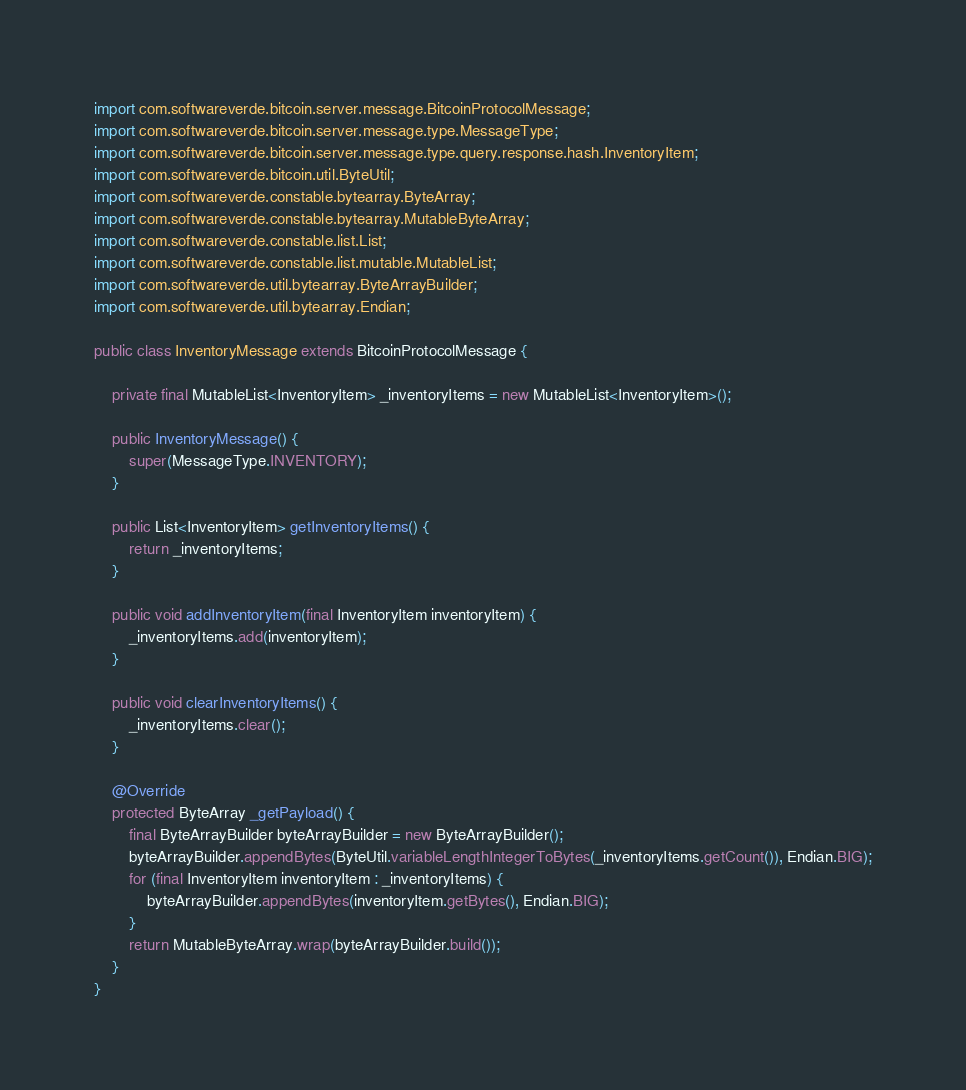<code> <loc_0><loc_0><loc_500><loc_500><_Java_>import com.softwareverde.bitcoin.server.message.BitcoinProtocolMessage;
import com.softwareverde.bitcoin.server.message.type.MessageType;
import com.softwareverde.bitcoin.server.message.type.query.response.hash.InventoryItem;
import com.softwareverde.bitcoin.util.ByteUtil;
import com.softwareverde.constable.bytearray.ByteArray;
import com.softwareverde.constable.bytearray.MutableByteArray;
import com.softwareverde.constable.list.List;
import com.softwareverde.constable.list.mutable.MutableList;
import com.softwareverde.util.bytearray.ByteArrayBuilder;
import com.softwareverde.util.bytearray.Endian;

public class InventoryMessage extends BitcoinProtocolMessage {

    private final MutableList<InventoryItem> _inventoryItems = new MutableList<InventoryItem>();

    public InventoryMessage() {
        super(MessageType.INVENTORY);
    }

    public List<InventoryItem> getInventoryItems() {
        return _inventoryItems;
    }

    public void addInventoryItem(final InventoryItem inventoryItem) {
        _inventoryItems.add(inventoryItem);
    }

    public void clearInventoryItems() {
        _inventoryItems.clear();
    }

    @Override
    protected ByteArray _getPayload() {
        final ByteArrayBuilder byteArrayBuilder = new ByteArrayBuilder();
        byteArrayBuilder.appendBytes(ByteUtil.variableLengthIntegerToBytes(_inventoryItems.getCount()), Endian.BIG);
        for (final InventoryItem inventoryItem : _inventoryItems) {
            byteArrayBuilder.appendBytes(inventoryItem.getBytes(), Endian.BIG);
        }
        return MutableByteArray.wrap(byteArrayBuilder.build());
    }
}
</code> 